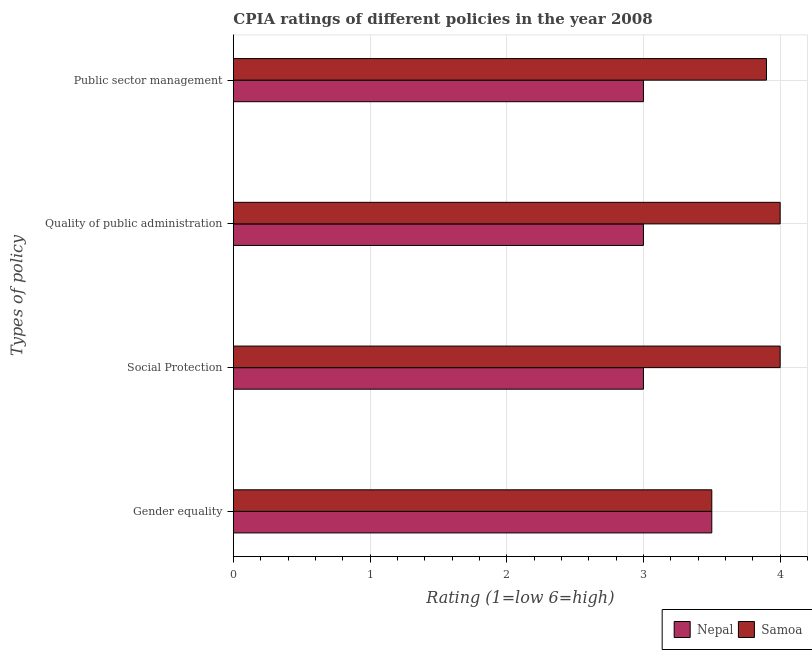How many different coloured bars are there?
Offer a terse response. 2. How many groups of bars are there?
Offer a very short reply. 4. Are the number of bars per tick equal to the number of legend labels?
Provide a short and direct response. Yes. Are the number of bars on each tick of the Y-axis equal?
Make the answer very short. Yes. What is the label of the 3rd group of bars from the top?
Your answer should be compact. Social Protection. What is the cpia rating of quality of public administration in Nepal?
Give a very brief answer. 3. In which country was the cpia rating of quality of public administration maximum?
Provide a succinct answer. Samoa. In which country was the cpia rating of quality of public administration minimum?
Offer a terse response. Nepal. What is the difference between the cpia rating of public sector management and cpia rating of gender equality in Nepal?
Your response must be concise. -0.5. In how many countries, is the cpia rating of social protection greater than 2.6 ?
Give a very brief answer. 2. What is the ratio of the cpia rating of quality of public administration in Nepal to that in Samoa?
Ensure brevity in your answer.  0.75. Is the difference between the cpia rating of gender equality in Nepal and Samoa greater than the difference between the cpia rating of quality of public administration in Nepal and Samoa?
Provide a succinct answer. Yes. What is the difference between the highest and the second highest cpia rating of social protection?
Give a very brief answer. 1. What is the difference between the highest and the lowest cpia rating of gender equality?
Offer a terse response. 0. In how many countries, is the cpia rating of gender equality greater than the average cpia rating of gender equality taken over all countries?
Your answer should be very brief. 0. Is it the case that in every country, the sum of the cpia rating of public sector management and cpia rating of gender equality is greater than the sum of cpia rating of quality of public administration and cpia rating of social protection?
Make the answer very short. No. What does the 1st bar from the top in Social Protection represents?
Give a very brief answer. Samoa. What does the 1st bar from the bottom in Public sector management represents?
Offer a very short reply. Nepal. How many bars are there?
Give a very brief answer. 8. How many countries are there in the graph?
Your response must be concise. 2. Are the values on the major ticks of X-axis written in scientific E-notation?
Your response must be concise. No. Does the graph contain any zero values?
Offer a terse response. No. Does the graph contain grids?
Make the answer very short. Yes. How many legend labels are there?
Provide a short and direct response. 2. What is the title of the graph?
Provide a succinct answer. CPIA ratings of different policies in the year 2008. What is the label or title of the Y-axis?
Keep it short and to the point. Types of policy. What is the Rating (1=low 6=high) in Nepal in Gender equality?
Your answer should be compact. 3.5. What is the Rating (1=low 6=high) of Samoa in Gender equality?
Your answer should be compact. 3.5. What is the Rating (1=low 6=high) in Samoa in Social Protection?
Keep it short and to the point. 4. What is the Rating (1=low 6=high) of Samoa in Quality of public administration?
Keep it short and to the point. 4. What is the Rating (1=low 6=high) in Samoa in Public sector management?
Ensure brevity in your answer.  3.9. Across all Types of policy, what is the maximum Rating (1=low 6=high) in Nepal?
Make the answer very short. 3.5. Across all Types of policy, what is the minimum Rating (1=low 6=high) in Nepal?
Provide a short and direct response. 3. Across all Types of policy, what is the minimum Rating (1=low 6=high) of Samoa?
Your answer should be very brief. 3.5. What is the total Rating (1=low 6=high) of Nepal in the graph?
Make the answer very short. 12.5. What is the difference between the Rating (1=low 6=high) of Nepal in Gender equality and that in Social Protection?
Ensure brevity in your answer.  0.5. What is the difference between the Rating (1=low 6=high) of Samoa in Gender equality and that in Social Protection?
Make the answer very short. -0.5. What is the difference between the Rating (1=low 6=high) in Samoa in Gender equality and that in Quality of public administration?
Offer a terse response. -0.5. What is the difference between the Rating (1=low 6=high) in Nepal in Gender equality and that in Public sector management?
Ensure brevity in your answer.  0.5. What is the difference between the Rating (1=low 6=high) of Samoa in Gender equality and that in Public sector management?
Provide a succinct answer. -0.4. What is the difference between the Rating (1=low 6=high) of Nepal in Social Protection and that in Quality of public administration?
Make the answer very short. 0. What is the difference between the Rating (1=low 6=high) in Samoa in Social Protection and that in Quality of public administration?
Keep it short and to the point. 0. What is the difference between the Rating (1=low 6=high) of Nepal in Quality of public administration and that in Public sector management?
Keep it short and to the point. 0. What is the difference between the Rating (1=low 6=high) of Nepal in Gender equality and the Rating (1=low 6=high) of Samoa in Quality of public administration?
Offer a very short reply. -0.5. What is the difference between the Rating (1=low 6=high) of Nepal in Gender equality and the Rating (1=low 6=high) of Samoa in Public sector management?
Offer a very short reply. -0.4. What is the difference between the Rating (1=low 6=high) of Nepal in Social Protection and the Rating (1=low 6=high) of Samoa in Quality of public administration?
Your answer should be very brief. -1. What is the difference between the Rating (1=low 6=high) of Nepal in Social Protection and the Rating (1=low 6=high) of Samoa in Public sector management?
Ensure brevity in your answer.  -0.9. What is the difference between the Rating (1=low 6=high) of Nepal in Quality of public administration and the Rating (1=low 6=high) of Samoa in Public sector management?
Provide a short and direct response. -0.9. What is the average Rating (1=low 6=high) in Nepal per Types of policy?
Give a very brief answer. 3.12. What is the average Rating (1=low 6=high) in Samoa per Types of policy?
Your answer should be very brief. 3.85. What is the difference between the Rating (1=low 6=high) in Nepal and Rating (1=low 6=high) in Samoa in Quality of public administration?
Offer a very short reply. -1. What is the ratio of the Rating (1=low 6=high) in Nepal in Gender equality to that in Social Protection?
Offer a terse response. 1.17. What is the ratio of the Rating (1=low 6=high) in Samoa in Gender equality to that in Social Protection?
Make the answer very short. 0.88. What is the ratio of the Rating (1=low 6=high) of Nepal in Gender equality to that in Quality of public administration?
Offer a very short reply. 1.17. What is the ratio of the Rating (1=low 6=high) in Samoa in Gender equality to that in Public sector management?
Provide a short and direct response. 0.9. What is the ratio of the Rating (1=low 6=high) of Nepal in Social Protection to that in Quality of public administration?
Your response must be concise. 1. What is the ratio of the Rating (1=low 6=high) of Samoa in Social Protection to that in Public sector management?
Your answer should be compact. 1.03. What is the ratio of the Rating (1=low 6=high) in Samoa in Quality of public administration to that in Public sector management?
Give a very brief answer. 1.03. 